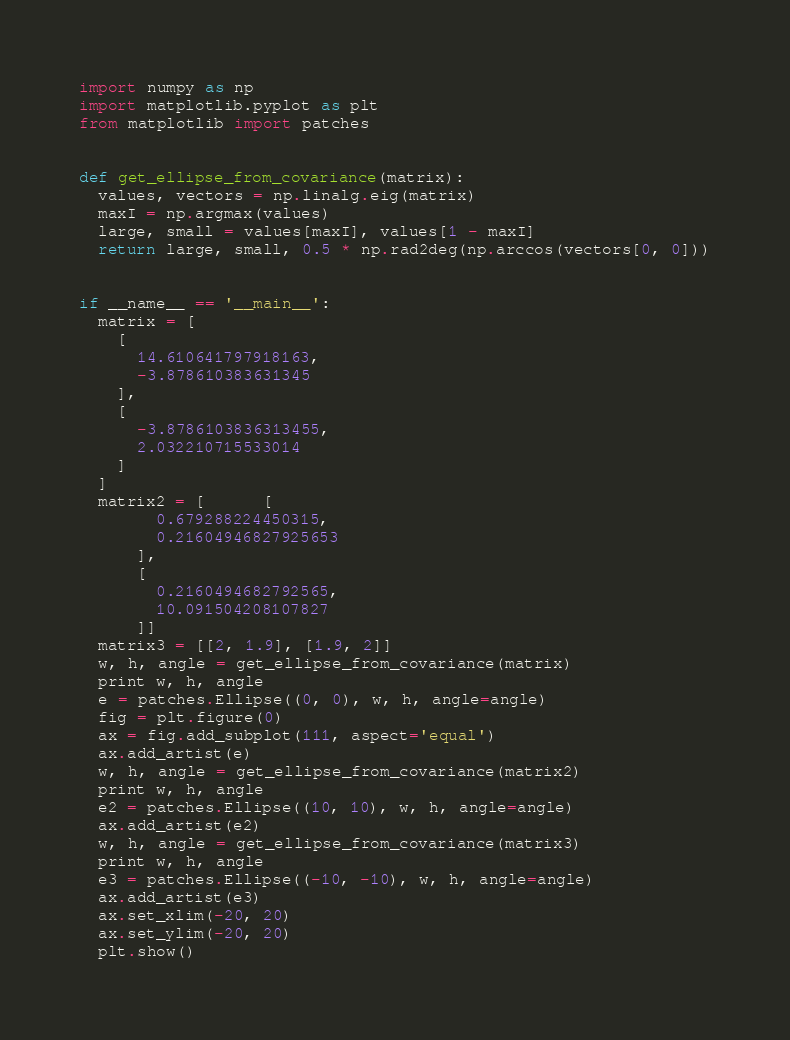<code> <loc_0><loc_0><loc_500><loc_500><_Python_>import numpy as np
import matplotlib.pyplot as plt
from matplotlib import patches


def get_ellipse_from_covariance(matrix):
  values, vectors = np.linalg.eig(matrix)
  maxI = np.argmax(values)
  large, small = values[maxI], values[1 - maxI]
  return large, small, 0.5 * np.rad2deg(np.arccos(vectors[0, 0]))


if __name__ == '__main__':
  matrix = [
    [
      14.610641797918163,
      -3.878610383631345
    ],
    [
      -3.8786103836313455,
      2.032210715533014
    ]
  ]
  matrix2 = [      [
        0.679288224450315,
        0.21604946827925653
      ],
      [
        0.2160494682792565,
        10.091504208107827
      ]]
  matrix3 = [[2, 1.9], [1.9, 2]]
  w, h, angle = get_ellipse_from_covariance(matrix)
  print w, h, angle
  e = patches.Ellipse((0, 0), w, h, angle=angle)
  fig = plt.figure(0)
  ax = fig.add_subplot(111, aspect='equal')
  ax.add_artist(e)
  w, h, angle = get_ellipse_from_covariance(matrix2)
  print w, h, angle
  e2 = patches.Ellipse((10, 10), w, h, angle=angle)
  ax.add_artist(e2)
  w, h, angle = get_ellipse_from_covariance(matrix3)
  print w, h, angle
  e3 = patches.Ellipse((-10, -10), w, h, angle=angle)
  ax.add_artist(e3)
  ax.set_xlim(-20, 20)
  ax.set_ylim(-20, 20)
  plt.show()
</code> 